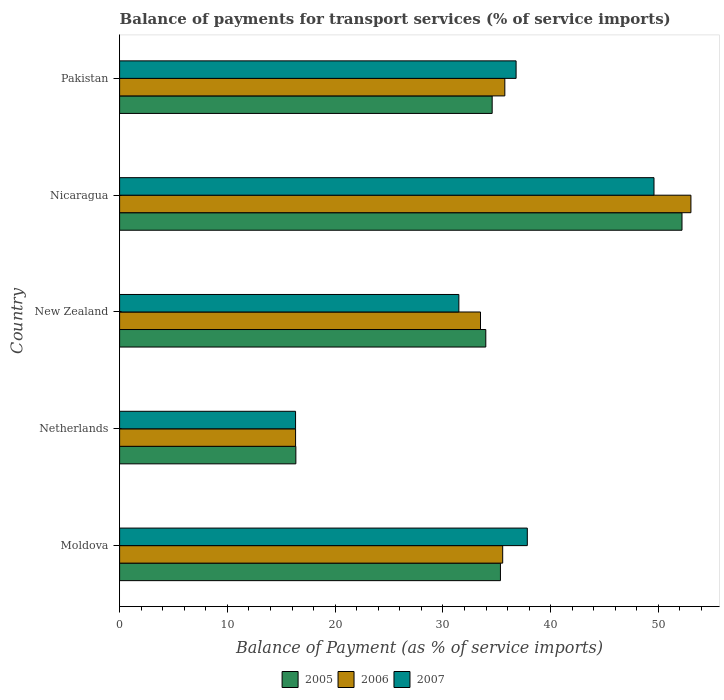How many different coloured bars are there?
Provide a succinct answer. 3. How many groups of bars are there?
Keep it short and to the point. 5. Are the number of bars on each tick of the Y-axis equal?
Your answer should be very brief. Yes. What is the label of the 3rd group of bars from the top?
Give a very brief answer. New Zealand. What is the balance of payments for transport services in 2007 in New Zealand?
Give a very brief answer. 31.48. Across all countries, what is the maximum balance of payments for transport services in 2006?
Your answer should be compact. 53.01. Across all countries, what is the minimum balance of payments for transport services in 2006?
Offer a very short reply. 16.33. In which country was the balance of payments for transport services in 2006 maximum?
Ensure brevity in your answer.  Nicaragua. What is the total balance of payments for transport services in 2006 in the graph?
Keep it short and to the point. 174.13. What is the difference between the balance of payments for transport services in 2007 in Netherlands and that in Nicaragua?
Provide a short and direct response. -33.26. What is the difference between the balance of payments for transport services in 2007 in Moldova and the balance of payments for transport services in 2005 in Pakistan?
Provide a succinct answer. 3.26. What is the average balance of payments for transport services in 2005 per country?
Keep it short and to the point. 34.49. What is the difference between the balance of payments for transport services in 2005 and balance of payments for transport services in 2007 in Moldova?
Give a very brief answer. -2.49. What is the ratio of the balance of payments for transport services in 2005 in Moldova to that in Pakistan?
Offer a terse response. 1.02. Is the balance of payments for transport services in 2005 in Moldova less than that in Nicaragua?
Your response must be concise. Yes. What is the difference between the highest and the second highest balance of payments for transport services in 2006?
Ensure brevity in your answer.  17.27. What is the difference between the highest and the lowest balance of payments for transport services in 2005?
Ensure brevity in your answer.  35.83. What does the 1st bar from the top in Netherlands represents?
Make the answer very short. 2007. Are all the bars in the graph horizontal?
Provide a succinct answer. Yes. How many countries are there in the graph?
Provide a succinct answer. 5. What is the difference between two consecutive major ticks on the X-axis?
Offer a terse response. 10. Does the graph contain any zero values?
Provide a succinct answer. No. Where does the legend appear in the graph?
Provide a short and direct response. Bottom center. How many legend labels are there?
Offer a very short reply. 3. How are the legend labels stacked?
Offer a very short reply. Horizontal. What is the title of the graph?
Provide a short and direct response. Balance of payments for transport services (% of service imports). What is the label or title of the X-axis?
Your response must be concise. Balance of Payment (as % of service imports). What is the label or title of the Y-axis?
Keep it short and to the point. Country. What is the Balance of Payment (as % of service imports) of 2005 in Moldova?
Offer a very short reply. 35.34. What is the Balance of Payment (as % of service imports) in 2006 in Moldova?
Offer a terse response. 35.55. What is the Balance of Payment (as % of service imports) of 2007 in Moldova?
Keep it short and to the point. 37.83. What is the Balance of Payment (as % of service imports) in 2005 in Netherlands?
Your response must be concise. 16.35. What is the Balance of Payment (as % of service imports) of 2006 in Netherlands?
Your response must be concise. 16.33. What is the Balance of Payment (as % of service imports) in 2007 in Netherlands?
Your answer should be very brief. 16.33. What is the Balance of Payment (as % of service imports) in 2005 in New Zealand?
Your response must be concise. 33.98. What is the Balance of Payment (as % of service imports) of 2006 in New Zealand?
Your answer should be very brief. 33.49. What is the Balance of Payment (as % of service imports) in 2007 in New Zealand?
Your answer should be compact. 31.48. What is the Balance of Payment (as % of service imports) of 2005 in Nicaragua?
Provide a succinct answer. 52.19. What is the Balance of Payment (as % of service imports) in 2006 in Nicaragua?
Keep it short and to the point. 53.01. What is the Balance of Payment (as % of service imports) in 2007 in Nicaragua?
Your answer should be compact. 49.59. What is the Balance of Payment (as % of service imports) in 2005 in Pakistan?
Keep it short and to the point. 34.57. What is the Balance of Payment (as % of service imports) in 2006 in Pakistan?
Your response must be concise. 35.75. What is the Balance of Payment (as % of service imports) of 2007 in Pakistan?
Your answer should be very brief. 36.79. Across all countries, what is the maximum Balance of Payment (as % of service imports) in 2005?
Your answer should be very brief. 52.19. Across all countries, what is the maximum Balance of Payment (as % of service imports) of 2006?
Offer a terse response. 53.01. Across all countries, what is the maximum Balance of Payment (as % of service imports) in 2007?
Offer a very short reply. 49.59. Across all countries, what is the minimum Balance of Payment (as % of service imports) in 2005?
Your response must be concise. 16.35. Across all countries, what is the minimum Balance of Payment (as % of service imports) in 2006?
Offer a very short reply. 16.33. Across all countries, what is the minimum Balance of Payment (as % of service imports) of 2007?
Provide a short and direct response. 16.33. What is the total Balance of Payment (as % of service imports) of 2005 in the graph?
Give a very brief answer. 172.43. What is the total Balance of Payment (as % of service imports) of 2006 in the graph?
Keep it short and to the point. 174.13. What is the total Balance of Payment (as % of service imports) of 2007 in the graph?
Your answer should be compact. 172.02. What is the difference between the Balance of Payment (as % of service imports) of 2005 in Moldova and that in Netherlands?
Make the answer very short. 18.98. What is the difference between the Balance of Payment (as % of service imports) of 2006 in Moldova and that in Netherlands?
Provide a short and direct response. 19.22. What is the difference between the Balance of Payment (as % of service imports) in 2007 in Moldova and that in Netherlands?
Give a very brief answer. 21.51. What is the difference between the Balance of Payment (as % of service imports) in 2005 in Moldova and that in New Zealand?
Provide a succinct answer. 1.36. What is the difference between the Balance of Payment (as % of service imports) in 2006 in Moldova and that in New Zealand?
Offer a very short reply. 2.06. What is the difference between the Balance of Payment (as % of service imports) in 2007 in Moldova and that in New Zealand?
Keep it short and to the point. 6.35. What is the difference between the Balance of Payment (as % of service imports) of 2005 in Moldova and that in Nicaragua?
Your answer should be very brief. -16.85. What is the difference between the Balance of Payment (as % of service imports) in 2006 in Moldova and that in Nicaragua?
Ensure brevity in your answer.  -17.47. What is the difference between the Balance of Payment (as % of service imports) of 2007 in Moldova and that in Nicaragua?
Your answer should be very brief. -11.75. What is the difference between the Balance of Payment (as % of service imports) of 2005 in Moldova and that in Pakistan?
Ensure brevity in your answer.  0.77. What is the difference between the Balance of Payment (as % of service imports) of 2006 in Moldova and that in Pakistan?
Offer a terse response. -0.2. What is the difference between the Balance of Payment (as % of service imports) of 2007 in Moldova and that in Pakistan?
Make the answer very short. 1.04. What is the difference between the Balance of Payment (as % of service imports) of 2005 in Netherlands and that in New Zealand?
Give a very brief answer. -17.63. What is the difference between the Balance of Payment (as % of service imports) of 2006 in Netherlands and that in New Zealand?
Offer a very short reply. -17.16. What is the difference between the Balance of Payment (as % of service imports) in 2007 in Netherlands and that in New Zealand?
Offer a terse response. -15.15. What is the difference between the Balance of Payment (as % of service imports) in 2005 in Netherlands and that in Nicaragua?
Your answer should be very brief. -35.83. What is the difference between the Balance of Payment (as % of service imports) in 2006 in Netherlands and that in Nicaragua?
Give a very brief answer. -36.69. What is the difference between the Balance of Payment (as % of service imports) of 2007 in Netherlands and that in Nicaragua?
Offer a terse response. -33.26. What is the difference between the Balance of Payment (as % of service imports) of 2005 in Netherlands and that in Pakistan?
Give a very brief answer. -18.22. What is the difference between the Balance of Payment (as % of service imports) in 2006 in Netherlands and that in Pakistan?
Ensure brevity in your answer.  -19.42. What is the difference between the Balance of Payment (as % of service imports) of 2007 in Netherlands and that in Pakistan?
Provide a succinct answer. -20.46. What is the difference between the Balance of Payment (as % of service imports) in 2005 in New Zealand and that in Nicaragua?
Provide a succinct answer. -18.21. What is the difference between the Balance of Payment (as % of service imports) of 2006 in New Zealand and that in Nicaragua?
Offer a terse response. -19.53. What is the difference between the Balance of Payment (as % of service imports) in 2007 in New Zealand and that in Nicaragua?
Your answer should be very brief. -18.11. What is the difference between the Balance of Payment (as % of service imports) in 2005 in New Zealand and that in Pakistan?
Your answer should be very brief. -0.59. What is the difference between the Balance of Payment (as % of service imports) in 2006 in New Zealand and that in Pakistan?
Ensure brevity in your answer.  -2.26. What is the difference between the Balance of Payment (as % of service imports) in 2007 in New Zealand and that in Pakistan?
Your answer should be very brief. -5.31. What is the difference between the Balance of Payment (as % of service imports) in 2005 in Nicaragua and that in Pakistan?
Offer a very short reply. 17.61. What is the difference between the Balance of Payment (as % of service imports) in 2006 in Nicaragua and that in Pakistan?
Your answer should be very brief. 17.27. What is the difference between the Balance of Payment (as % of service imports) in 2007 in Nicaragua and that in Pakistan?
Your response must be concise. 12.8. What is the difference between the Balance of Payment (as % of service imports) in 2005 in Moldova and the Balance of Payment (as % of service imports) in 2006 in Netherlands?
Provide a short and direct response. 19.01. What is the difference between the Balance of Payment (as % of service imports) of 2005 in Moldova and the Balance of Payment (as % of service imports) of 2007 in Netherlands?
Provide a succinct answer. 19.01. What is the difference between the Balance of Payment (as % of service imports) in 2006 in Moldova and the Balance of Payment (as % of service imports) in 2007 in Netherlands?
Keep it short and to the point. 19.22. What is the difference between the Balance of Payment (as % of service imports) in 2005 in Moldova and the Balance of Payment (as % of service imports) in 2006 in New Zealand?
Make the answer very short. 1.85. What is the difference between the Balance of Payment (as % of service imports) of 2005 in Moldova and the Balance of Payment (as % of service imports) of 2007 in New Zealand?
Your answer should be very brief. 3.86. What is the difference between the Balance of Payment (as % of service imports) of 2006 in Moldova and the Balance of Payment (as % of service imports) of 2007 in New Zealand?
Offer a very short reply. 4.07. What is the difference between the Balance of Payment (as % of service imports) of 2005 in Moldova and the Balance of Payment (as % of service imports) of 2006 in Nicaragua?
Your response must be concise. -17.68. What is the difference between the Balance of Payment (as % of service imports) of 2005 in Moldova and the Balance of Payment (as % of service imports) of 2007 in Nicaragua?
Your answer should be compact. -14.25. What is the difference between the Balance of Payment (as % of service imports) of 2006 in Moldova and the Balance of Payment (as % of service imports) of 2007 in Nicaragua?
Provide a succinct answer. -14.04. What is the difference between the Balance of Payment (as % of service imports) of 2005 in Moldova and the Balance of Payment (as % of service imports) of 2006 in Pakistan?
Offer a very short reply. -0.41. What is the difference between the Balance of Payment (as % of service imports) of 2005 in Moldova and the Balance of Payment (as % of service imports) of 2007 in Pakistan?
Your response must be concise. -1.45. What is the difference between the Balance of Payment (as % of service imports) in 2006 in Moldova and the Balance of Payment (as % of service imports) in 2007 in Pakistan?
Provide a succinct answer. -1.24. What is the difference between the Balance of Payment (as % of service imports) of 2005 in Netherlands and the Balance of Payment (as % of service imports) of 2006 in New Zealand?
Provide a succinct answer. -17.13. What is the difference between the Balance of Payment (as % of service imports) in 2005 in Netherlands and the Balance of Payment (as % of service imports) in 2007 in New Zealand?
Make the answer very short. -15.13. What is the difference between the Balance of Payment (as % of service imports) in 2006 in Netherlands and the Balance of Payment (as % of service imports) in 2007 in New Zealand?
Keep it short and to the point. -15.15. What is the difference between the Balance of Payment (as % of service imports) in 2005 in Netherlands and the Balance of Payment (as % of service imports) in 2006 in Nicaragua?
Give a very brief answer. -36.66. What is the difference between the Balance of Payment (as % of service imports) in 2005 in Netherlands and the Balance of Payment (as % of service imports) in 2007 in Nicaragua?
Offer a terse response. -33.23. What is the difference between the Balance of Payment (as % of service imports) of 2006 in Netherlands and the Balance of Payment (as % of service imports) of 2007 in Nicaragua?
Keep it short and to the point. -33.26. What is the difference between the Balance of Payment (as % of service imports) of 2005 in Netherlands and the Balance of Payment (as % of service imports) of 2006 in Pakistan?
Your response must be concise. -19.39. What is the difference between the Balance of Payment (as % of service imports) in 2005 in Netherlands and the Balance of Payment (as % of service imports) in 2007 in Pakistan?
Provide a short and direct response. -20.44. What is the difference between the Balance of Payment (as % of service imports) in 2006 in Netherlands and the Balance of Payment (as % of service imports) in 2007 in Pakistan?
Provide a short and direct response. -20.46. What is the difference between the Balance of Payment (as % of service imports) of 2005 in New Zealand and the Balance of Payment (as % of service imports) of 2006 in Nicaragua?
Give a very brief answer. -19.03. What is the difference between the Balance of Payment (as % of service imports) in 2005 in New Zealand and the Balance of Payment (as % of service imports) in 2007 in Nicaragua?
Ensure brevity in your answer.  -15.61. What is the difference between the Balance of Payment (as % of service imports) in 2006 in New Zealand and the Balance of Payment (as % of service imports) in 2007 in Nicaragua?
Your response must be concise. -16.1. What is the difference between the Balance of Payment (as % of service imports) in 2005 in New Zealand and the Balance of Payment (as % of service imports) in 2006 in Pakistan?
Offer a terse response. -1.77. What is the difference between the Balance of Payment (as % of service imports) in 2005 in New Zealand and the Balance of Payment (as % of service imports) in 2007 in Pakistan?
Your answer should be very brief. -2.81. What is the difference between the Balance of Payment (as % of service imports) in 2006 in New Zealand and the Balance of Payment (as % of service imports) in 2007 in Pakistan?
Provide a short and direct response. -3.3. What is the difference between the Balance of Payment (as % of service imports) in 2005 in Nicaragua and the Balance of Payment (as % of service imports) in 2006 in Pakistan?
Your answer should be very brief. 16.44. What is the difference between the Balance of Payment (as % of service imports) in 2005 in Nicaragua and the Balance of Payment (as % of service imports) in 2007 in Pakistan?
Offer a terse response. 15.39. What is the difference between the Balance of Payment (as % of service imports) in 2006 in Nicaragua and the Balance of Payment (as % of service imports) in 2007 in Pakistan?
Your response must be concise. 16.22. What is the average Balance of Payment (as % of service imports) of 2005 per country?
Give a very brief answer. 34.49. What is the average Balance of Payment (as % of service imports) of 2006 per country?
Your answer should be very brief. 34.83. What is the average Balance of Payment (as % of service imports) of 2007 per country?
Offer a terse response. 34.4. What is the difference between the Balance of Payment (as % of service imports) in 2005 and Balance of Payment (as % of service imports) in 2006 in Moldova?
Your answer should be compact. -0.21. What is the difference between the Balance of Payment (as % of service imports) in 2005 and Balance of Payment (as % of service imports) in 2007 in Moldova?
Keep it short and to the point. -2.49. What is the difference between the Balance of Payment (as % of service imports) in 2006 and Balance of Payment (as % of service imports) in 2007 in Moldova?
Provide a succinct answer. -2.29. What is the difference between the Balance of Payment (as % of service imports) of 2005 and Balance of Payment (as % of service imports) of 2006 in Netherlands?
Keep it short and to the point. 0.03. What is the difference between the Balance of Payment (as % of service imports) in 2005 and Balance of Payment (as % of service imports) in 2007 in Netherlands?
Provide a succinct answer. 0.03. What is the difference between the Balance of Payment (as % of service imports) of 2006 and Balance of Payment (as % of service imports) of 2007 in Netherlands?
Provide a short and direct response. 0. What is the difference between the Balance of Payment (as % of service imports) in 2005 and Balance of Payment (as % of service imports) in 2006 in New Zealand?
Provide a short and direct response. 0.49. What is the difference between the Balance of Payment (as % of service imports) in 2005 and Balance of Payment (as % of service imports) in 2007 in New Zealand?
Provide a short and direct response. 2.5. What is the difference between the Balance of Payment (as % of service imports) of 2006 and Balance of Payment (as % of service imports) of 2007 in New Zealand?
Ensure brevity in your answer.  2.01. What is the difference between the Balance of Payment (as % of service imports) in 2005 and Balance of Payment (as % of service imports) in 2006 in Nicaragua?
Provide a succinct answer. -0.83. What is the difference between the Balance of Payment (as % of service imports) in 2005 and Balance of Payment (as % of service imports) in 2007 in Nicaragua?
Your answer should be compact. 2.6. What is the difference between the Balance of Payment (as % of service imports) of 2006 and Balance of Payment (as % of service imports) of 2007 in Nicaragua?
Make the answer very short. 3.43. What is the difference between the Balance of Payment (as % of service imports) in 2005 and Balance of Payment (as % of service imports) in 2006 in Pakistan?
Ensure brevity in your answer.  -1.17. What is the difference between the Balance of Payment (as % of service imports) in 2005 and Balance of Payment (as % of service imports) in 2007 in Pakistan?
Provide a short and direct response. -2.22. What is the difference between the Balance of Payment (as % of service imports) in 2006 and Balance of Payment (as % of service imports) in 2007 in Pakistan?
Provide a succinct answer. -1.04. What is the ratio of the Balance of Payment (as % of service imports) in 2005 in Moldova to that in Netherlands?
Your answer should be compact. 2.16. What is the ratio of the Balance of Payment (as % of service imports) in 2006 in Moldova to that in Netherlands?
Keep it short and to the point. 2.18. What is the ratio of the Balance of Payment (as % of service imports) in 2007 in Moldova to that in Netherlands?
Make the answer very short. 2.32. What is the ratio of the Balance of Payment (as % of service imports) of 2006 in Moldova to that in New Zealand?
Provide a succinct answer. 1.06. What is the ratio of the Balance of Payment (as % of service imports) of 2007 in Moldova to that in New Zealand?
Keep it short and to the point. 1.2. What is the ratio of the Balance of Payment (as % of service imports) in 2005 in Moldova to that in Nicaragua?
Offer a very short reply. 0.68. What is the ratio of the Balance of Payment (as % of service imports) of 2006 in Moldova to that in Nicaragua?
Offer a very short reply. 0.67. What is the ratio of the Balance of Payment (as % of service imports) in 2007 in Moldova to that in Nicaragua?
Provide a short and direct response. 0.76. What is the ratio of the Balance of Payment (as % of service imports) in 2005 in Moldova to that in Pakistan?
Provide a succinct answer. 1.02. What is the ratio of the Balance of Payment (as % of service imports) of 2007 in Moldova to that in Pakistan?
Make the answer very short. 1.03. What is the ratio of the Balance of Payment (as % of service imports) in 2005 in Netherlands to that in New Zealand?
Your answer should be compact. 0.48. What is the ratio of the Balance of Payment (as % of service imports) in 2006 in Netherlands to that in New Zealand?
Give a very brief answer. 0.49. What is the ratio of the Balance of Payment (as % of service imports) of 2007 in Netherlands to that in New Zealand?
Your answer should be very brief. 0.52. What is the ratio of the Balance of Payment (as % of service imports) of 2005 in Netherlands to that in Nicaragua?
Offer a very short reply. 0.31. What is the ratio of the Balance of Payment (as % of service imports) in 2006 in Netherlands to that in Nicaragua?
Ensure brevity in your answer.  0.31. What is the ratio of the Balance of Payment (as % of service imports) of 2007 in Netherlands to that in Nicaragua?
Provide a short and direct response. 0.33. What is the ratio of the Balance of Payment (as % of service imports) in 2005 in Netherlands to that in Pakistan?
Make the answer very short. 0.47. What is the ratio of the Balance of Payment (as % of service imports) of 2006 in Netherlands to that in Pakistan?
Offer a terse response. 0.46. What is the ratio of the Balance of Payment (as % of service imports) of 2007 in Netherlands to that in Pakistan?
Offer a terse response. 0.44. What is the ratio of the Balance of Payment (as % of service imports) of 2005 in New Zealand to that in Nicaragua?
Your answer should be compact. 0.65. What is the ratio of the Balance of Payment (as % of service imports) in 2006 in New Zealand to that in Nicaragua?
Provide a succinct answer. 0.63. What is the ratio of the Balance of Payment (as % of service imports) in 2007 in New Zealand to that in Nicaragua?
Make the answer very short. 0.63. What is the ratio of the Balance of Payment (as % of service imports) in 2005 in New Zealand to that in Pakistan?
Make the answer very short. 0.98. What is the ratio of the Balance of Payment (as % of service imports) in 2006 in New Zealand to that in Pakistan?
Keep it short and to the point. 0.94. What is the ratio of the Balance of Payment (as % of service imports) in 2007 in New Zealand to that in Pakistan?
Your response must be concise. 0.86. What is the ratio of the Balance of Payment (as % of service imports) of 2005 in Nicaragua to that in Pakistan?
Offer a very short reply. 1.51. What is the ratio of the Balance of Payment (as % of service imports) of 2006 in Nicaragua to that in Pakistan?
Offer a very short reply. 1.48. What is the ratio of the Balance of Payment (as % of service imports) in 2007 in Nicaragua to that in Pakistan?
Provide a succinct answer. 1.35. What is the difference between the highest and the second highest Balance of Payment (as % of service imports) in 2005?
Your answer should be compact. 16.85. What is the difference between the highest and the second highest Balance of Payment (as % of service imports) of 2006?
Your answer should be very brief. 17.27. What is the difference between the highest and the second highest Balance of Payment (as % of service imports) of 2007?
Your answer should be compact. 11.75. What is the difference between the highest and the lowest Balance of Payment (as % of service imports) in 2005?
Ensure brevity in your answer.  35.83. What is the difference between the highest and the lowest Balance of Payment (as % of service imports) of 2006?
Provide a short and direct response. 36.69. What is the difference between the highest and the lowest Balance of Payment (as % of service imports) of 2007?
Ensure brevity in your answer.  33.26. 